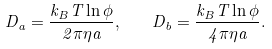Convert formula to latex. <formula><loc_0><loc_0><loc_500><loc_500>D _ { a } = \frac { k _ { B } T \ln \phi } { 2 \pi \eta a } , \quad D _ { b } = \frac { k _ { B } T \ln \phi } { 4 \pi \eta a } .</formula> 